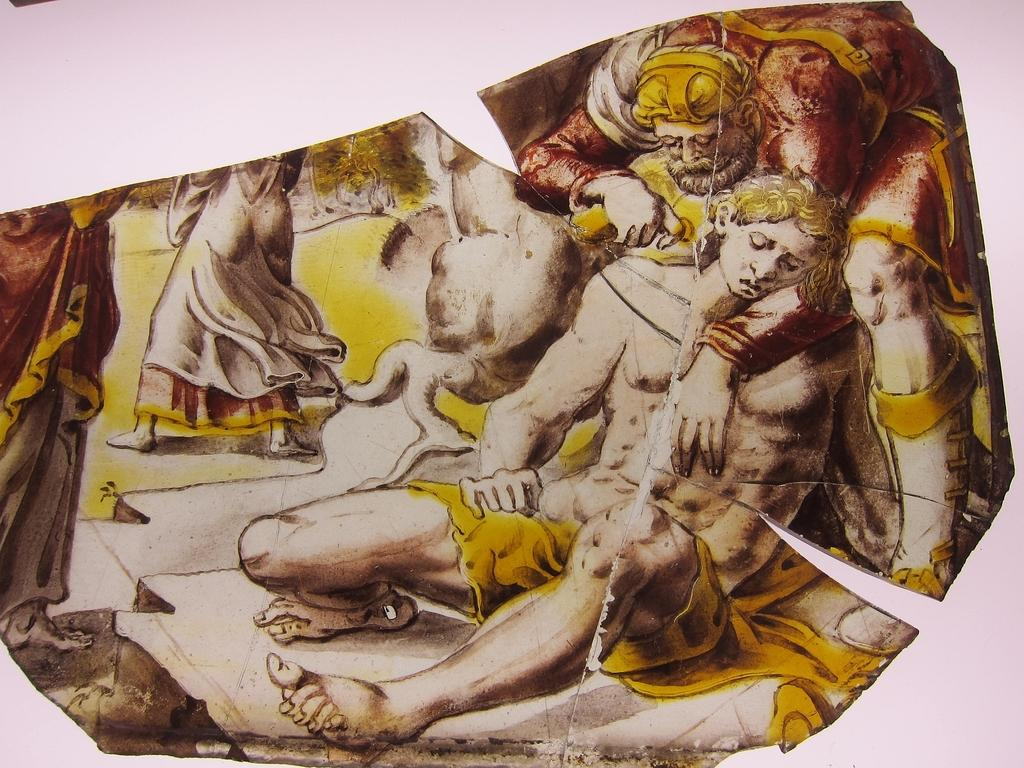What is the main subject of the image? There is an art piece or painting in the image. Can you describe the colors used in the art piece or painting? The art piece or painting is in yellow and cream colors. What else can be observed in the art piece or painting? There are people depicted in the art piece or painting. Can you tell me how many twigs are used in the art piece or painting? There is no mention of twigs in the image or the provided facts, so it is impossible to determine their presence or quantity. 